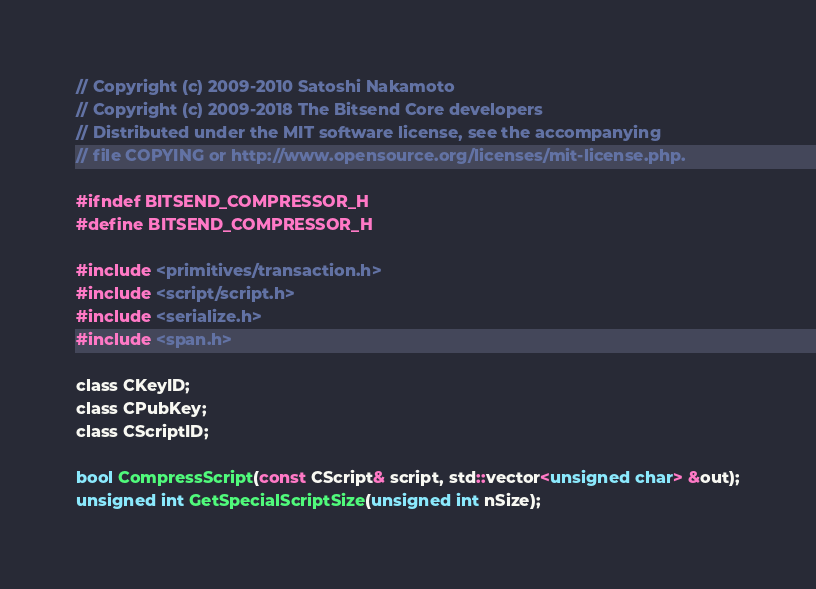Convert code to text. <code><loc_0><loc_0><loc_500><loc_500><_C_>// Copyright (c) 2009-2010 Satoshi Nakamoto
// Copyright (c) 2009-2018 The Bitsend Core developers
// Distributed under the MIT software license, see the accompanying
// file COPYING or http://www.opensource.org/licenses/mit-license.php.

#ifndef BITSEND_COMPRESSOR_H
#define BITSEND_COMPRESSOR_H

#include <primitives/transaction.h>
#include <script/script.h>
#include <serialize.h>
#include <span.h>

class CKeyID;
class CPubKey;
class CScriptID;

bool CompressScript(const CScript& script, std::vector<unsigned char> &out);
unsigned int GetSpecialScriptSize(unsigned int nSize);</code> 